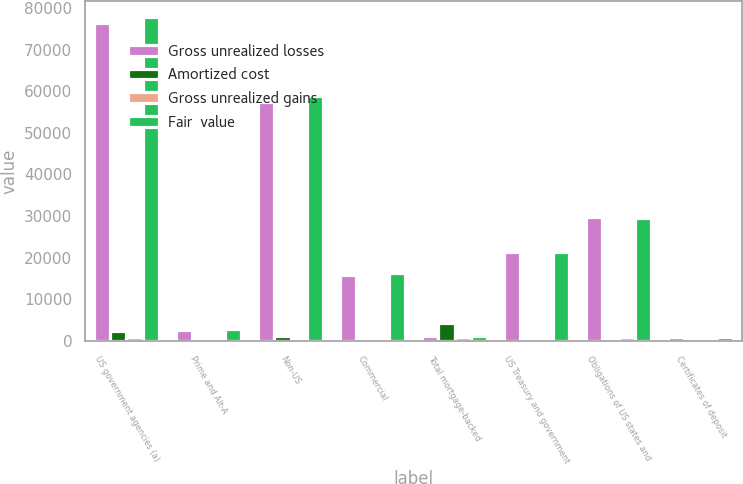<chart> <loc_0><loc_0><loc_500><loc_500><stacked_bar_chart><ecel><fcel>US government agencies (a)<fcel>Prime and Alt-A<fcel>Non-US<fcel>Commercial<fcel>Total mortgage-backed<fcel>US Treasury and government<fcel>Obligations of US states and<fcel>Certificates of deposit<nl><fcel>Gross unrealized losses<fcel>76428<fcel>2744<fcel>57448<fcel>15891<fcel>1177.5<fcel>21310<fcel>29741<fcel>1041<nl><fcel>Amortized cost<fcel>2364<fcel>61<fcel>1314<fcel>560<fcel>4322<fcel>385<fcel>707<fcel>1<nl><fcel>Gross unrealized gains<fcel>977<fcel>27<fcel>1<fcel>26<fcel>1032<fcel>306<fcel>987<fcel>1<nl><fcel>Fair  value<fcel>77815<fcel>2778<fcel>58761<fcel>16425<fcel>1177.5<fcel>21389<fcel>29461<fcel>1041<nl></chart> 